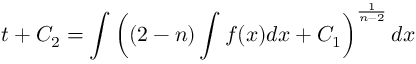<formula> <loc_0><loc_0><loc_500><loc_500>t + C _ { 2 } = \int \left ( ( 2 - n ) \int f ( x ) d x + C _ { 1 } \right ) ^ { \frac { 1 } { n - 2 } } d x</formula> 